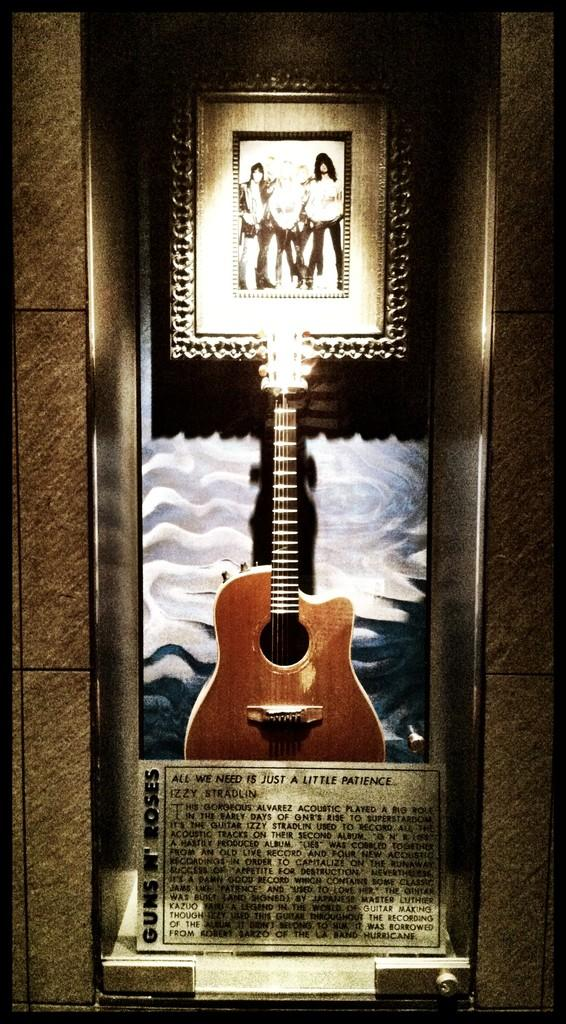What musical instrument is present in the image? There is a guitar in the image. What type of object is used for displaying photos in the image? There is a photo frame in the image. What can be seen on the wall in the image? There is a texted board in the image. What type of structure is visible in the image? There is a wall in the image. How many pies are being served on the volleyball court in the image? There are no pies or volleyball court present in the image. What type of pain is being experienced by the person in the image? There is no person experiencing pain in the image. 